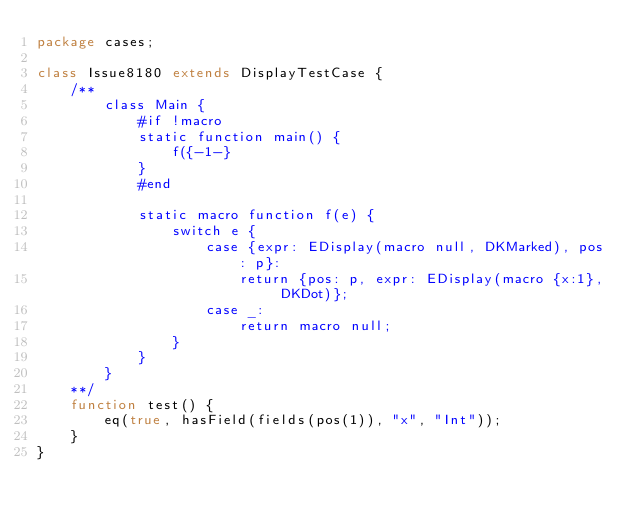<code> <loc_0><loc_0><loc_500><loc_500><_Haxe_>package cases;

class Issue8180 extends DisplayTestCase {
	/**
		class Main {
			#if !macro
			static function main() {
				f({-1-}
			}
			#end

			static macro function f(e) {
				switch e {
					case {expr: EDisplay(macro null, DKMarked), pos: p}:
						return {pos: p, expr: EDisplay(macro {x:1}, DKDot)};
					case _:
						return macro null;
				}
			}
		}
	**/
	function test() {
		eq(true, hasField(fields(pos(1)), "x", "Int"));
	}
}
</code> 